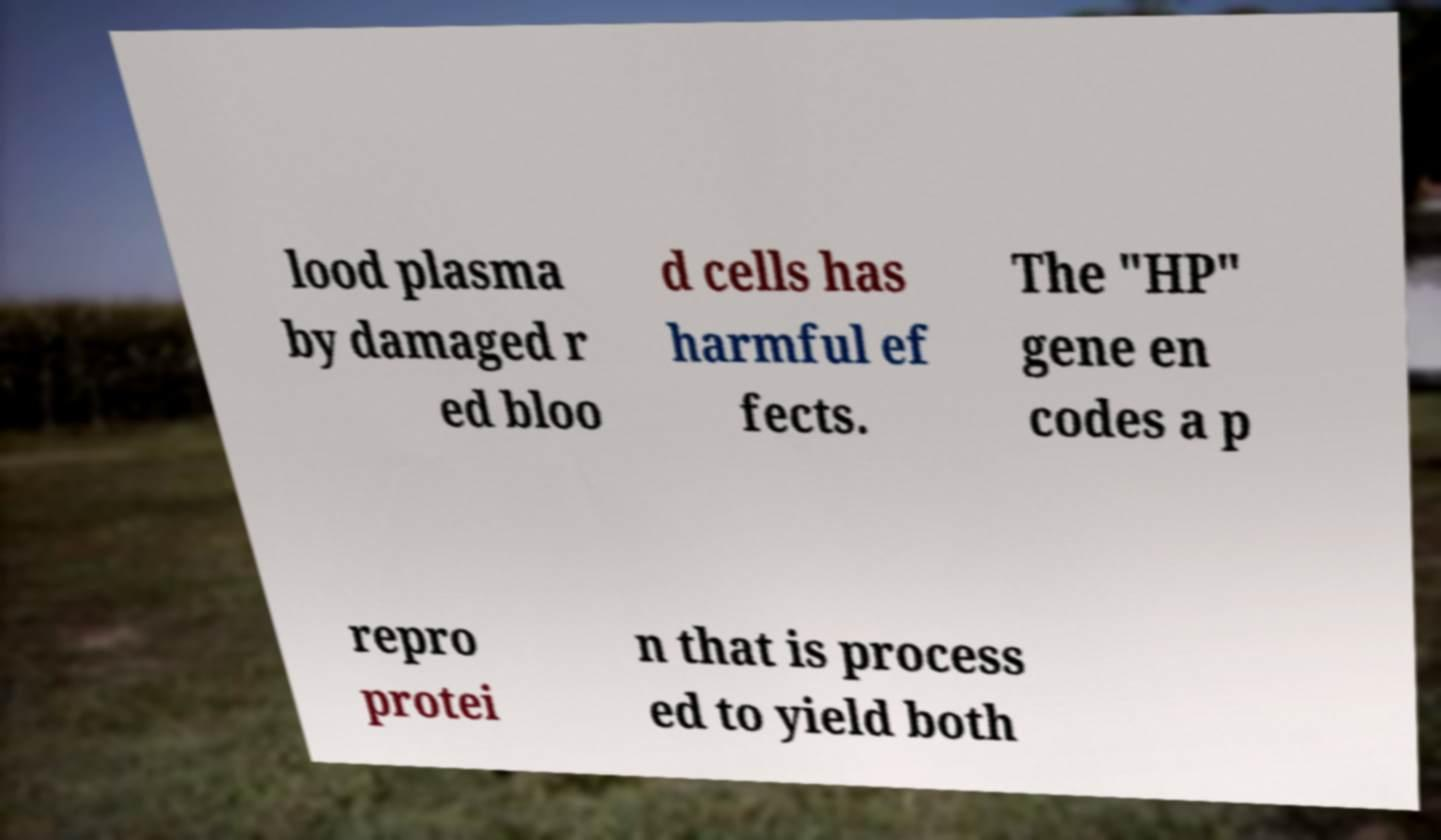Please identify and transcribe the text found in this image. lood plasma by damaged r ed bloo d cells has harmful ef fects. The "HP" gene en codes a p repro protei n that is process ed to yield both 